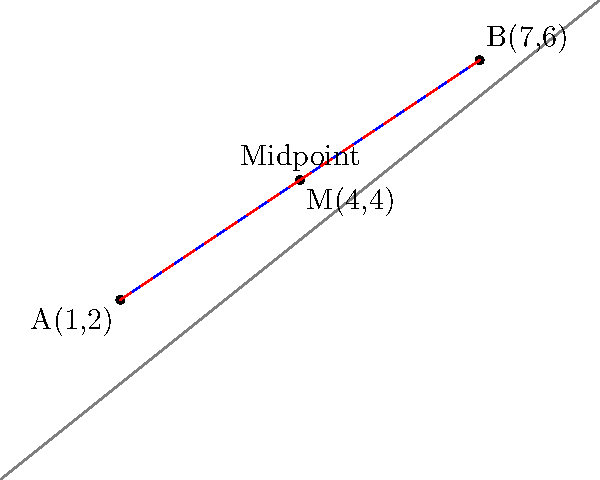Two colleagues, represented by points A(1,2) and B(7,6) on a coordinate plane, need to find a compromise for a project decision. To meet halfway, they decide to use the midpoint formula. Calculate the coordinates of the midpoint M between A and B, which represents their compromise. To find the midpoint M between two points A(x₁, y₁) and B(x₂, y₂), we use the midpoint formula:

$$ M = (\frac{x_1 + x_2}{2}, \frac{y_1 + y_2}{2}) $$

Given:
A(1,2) and B(7,6)

Step 1: Calculate the x-coordinate of the midpoint:
$$ x_M = \frac{x_1 + x_2}{2} = \frac{1 + 7}{2} = \frac{8}{2} = 4 $$

Step 2: Calculate the y-coordinate of the midpoint:
$$ y_M = \frac{y_1 + y_2}{2} = \frac{2 + 6}{2} = \frac{8}{2} = 4 $$

Step 3: Combine the results to get the midpoint coordinates:
M(4,4)

Therefore, the midpoint M, representing the compromise between the two colleagues, is located at (4,4) on the coordinate plane.
Answer: M(4,4) 